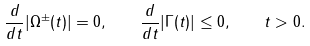Convert formula to latex. <formula><loc_0><loc_0><loc_500><loc_500>\frac { d } { d t } | \Omega ^ { \pm } ( t ) | = 0 , \quad \frac { d } { d t } | \Gamma ( t ) | \leq 0 , \quad t > 0 .</formula> 